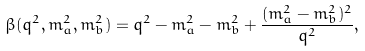<formula> <loc_0><loc_0><loc_500><loc_500>\beta ( q ^ { 2 } , m _ { a } ^ { 2 } , m _ { b } ^ { 2 } ) = q ^ { 2 } - m _ { a } ^ { 2 } - m _ { b } ^ { 2 } + \frac { ( m _ { a } ^ { 2 } - m _ { b } ^ { 2 } ) ^ { 2 } } { q ^ { 2 } } ,</formula> 